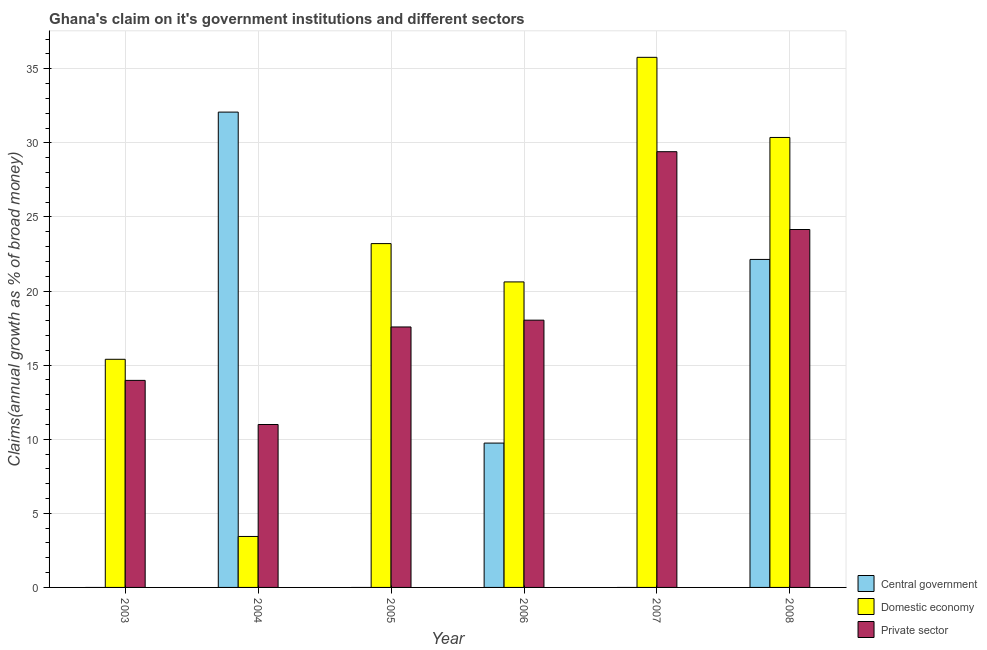How many different coloured bars are there?
Make the answer very short. 3. Are the number of bars per tick equal to the number of legend labels?
Provide a succinct answer. No. Are the number of bars on each tick of the X-axis equal?
Ensure brevity in your answer.  No. How many bars are there on the 6th tick from the left?
Offer a very short reply. 3. What is the percentage of claim on the private sector in 2004?
Offer a terse response. 10.99. Across all years, what is the maximum percentage of claim on the central government?
Provide a short and direct response. 32.08. Across all years, what is the minimum percentage of claim on the domestic economy?
Make the answer very short. 3.44. What is the total percentage of claim on the domestic economy in the graph?
Offer a very short reply. 128.79. What is the difference between the percentage of claim on the domestic economy in 2004 and that in 2008?
Offer a very short reply. -26.93. What is the difference between the percentage of claim on the private sector in 2007 and the percentage of claim on the central government in 2008?
Your response must be concise. 5.25. What is the average percentage of claim on the domestic economy per year?
Provide a succinct answer. 21.47. In the year 2003, what is the difference between the percentage of claim on the private sector and percentage of claim on the central government?
Your response must be concise. 0. What is the ratio of the percentage of claim on the private sector in 2004 to that in 2008?
Give a very brief answer. 0.46. Is the percentage of claim on the domestic economy in 2004 less than that in 2007?
Give a very brief answer. Yes. What is the difference between the highest and the second highest percentage of claim on the central government?
Your answer should be very brief. 9.94. What is the difference between the highest and the lowest percentage of claim on the central government?
Offer a very short reply. 32.08. Is the sum of the percentage of claim on the domestic economy in 2006 and 2008 greater than the maximum percentage of claim on the private sector across all years?
Make the answer very short. Yes. Is it the case that in every year, the sum of the percentage of claim on the central government and percentage of claim on the domestic economy is greater than the percentage of claim on the private sector?
Ensure brevity in your answer.  Yes. Are all the bars in the graph horizontal?
Your answer should be compact. No. Are the values on the major ticks of Y-axis written in scientific E-notation?
Keep it short and to the point. No. Does the graph contain any zero values?
Your response must be concise. Yes. Where does the legend appear in the graph?
Your response must be concise. Bottom right. How are the legend labels stacked?
Your answer should be very brief. Vertical. What is the title of the graph?
Provide a succinct answer. Ghana's claim on it's government institutions and different sectors. Does "Machinery" appear as one of the legend labels in the graph?
Provide a short and direct response. No. What is the label or title of the X-axis?
Ensure brevity in your answer.  Year. What is the label or title of the Y-axis?
Provide a short and direct response. Claims(annual growth as % of broad money). What is the Claims(annual growth as % of broad money) of Domestic economy in 2003?
Provide a succinct answer. 15.4. What is the Claims(annual growth as % of broad money) in Private sector in 2003?
Your answer should be compact. 13.97. What is the Claims(annual growth as % of broad money) of Central government in 2004?
Provide a short and direct response. 32.08. What is the Claims(annual growth as % of broad money) in Domestic economy in 2004?
Provide a short and direct response. 3.44. What is the Claims(annual growth as % of broad money) in Private sector in 2004?
Provide a short and direct response. 10.99. What is the Claims(annual growth as % of broad money) of Domestic economy in 2005?
Ensure brevity in your answer.  23.2. What is the Claims(annual growth as % of broad money) in Private sector in 2005?
Make the answer very short. 17.58. What is the Claims(annual growth as % of broad money) in Central government in 2006?
Keep it short and to the point. 9.74. What is the Claims(annual growth as % of broad money) in Domestic economy in 2006?
Provide a succinct answer. 20.62. What is the Claims(annual growth as % of broad money) in Private sector in 2006?
Give a very brief answer. 18.04. What is the Claims(annual growth as % of broad money) of Domestic economy in 2007?
Your response must be concise. 35.77. What is the Claims(annual growth as % of broad money) in Private sector in 2007?
Keep it short and to the point. 29.41. What is the Claims(annual growth as % of broad money) in Central government in 2008?
Your answer should be very brief. 22.13. What is the Claims(annual growth as % of broad money) of Domestic economy in 2008?
Your response must be concise. 30.37. What is the Claims(annual growth as % of broad money) of Private sector in 2008?
Your answer should be compact. 24.15. Across all years, what is the maximum Claims(annual growth as % of broad money) of Central government?
Keep it short and to the point. 32.08. Across all years, what is the maximum Claims(annual growth as % of broad money) in Domestic economy?
Your answer should be compact. 35.77. Across all years, what is the maximum Claims(annual growth as % of broad money) of Private sector?
Provide a short and direct response. 29.41. Across all years, what is the minimum Claims(annual growth as % of broad money) in Central government?
Ensure brevity in your answer.  0. Across all years, what is the minimum Claims(annual growth as % of broad money) in Domestic economy?
Your response must be concise. 3.44. Across all years, what is the minimum Claims(annual growth as % of broad money) in Private sector?
Give a very brief answer. 10.99. What is the total Claims(annual growth as % of broad money) of Central government in the graph?
Provide a short and direct response. 63.95. What is the total Claims(annual growth as % of broad money) of Domestic economy in the graph?
Offer a very short reply. 128.79. What is the total Claims(annual growth as % of broad money) of Private sector in the graph?
Your answer should be compact. 114.14. What is the difference between the Claims(annual growth as % of broad money) in Domestic economy in 2003 and that in 2004?
Offer a very short reply. 11.96. What is the difference between the Claims(annual growth as % of broad money) of Private sector in 2003 and that in 2004?
Make the answer very short. 2.98. What is the difference between the Claims(annual growth as % of broad money) of Domestic economy in 2003 and that in 2005?
Your response must be concise. -7.81. What is the difference between the Claims(annual growth as % of broad money) in Private sector in 2003 and that in 2005?
Your answer should be very brief. -3.61. What is the difference between the Claims(annual growth as % of broad money) of Domestic economy in 2003 and that in 2006?
Your answer should be very brief. -5.22. What is the difference between the Claims(annual growth as % of broad money) in Private sector in 2003 and that in 2006?
Keep it short and to the point. -4.06. What is the difference between the Claims(annual growth as % of broad money) of Domestic economy in 2003 and that in 2007?
Keep it short and to the point. -20.38. What is the difference between the Claims(annual growth as % of broad money) in Private sector in 2003 and that in 2007?
Make the answer very short. -15.43. What is the difference between the Claims(annual growth as % of broad money) of Domestic economy in 2003 and that in 2008?
Give a very brief answer. -14.97. What is the difference between the Claims(annual growth as % of broad money) of Private sector in 2003 and that in 2008?
Your answer should be very brief. -10.18. What is the difference between the Claims(annual growth as % of broad money) of Domestic economy in 2004 and that in 2005?
Provide a short and direct response. -19.76. What is the difference between the Claims(annual growth as % of broad money) in Private sector in 2004 and that in 2005?
Ensure brevity in your answer.  -6.58. What is the difference between the Claims(annual growth as % of broad money) in Central government in 2004 and that in 2006?
Offer a very short reply. 22.34. What is the difference between the Claims(annual growth as % of broad money) in Domestic economy in 2004 and that in 2006?
Keep it short and to the point. -17.18. What is the difference between the Claims(annual growth as % of broad money) in Private sector in 2004 and that in 2006?
Give a very brief answer. -7.04. What is the difference between the Claims(annual growth as % of broad money) in Domestic economy in 2004 and that in 2007?
Offer a terse response. -32.33. What is the difference between the Claims(annual growth as % of broad money) in Private sector in 2004 and that in 2007?
Provide a succinct answer. -18.41. What is the difference between the Claims(annual growth as % of broad money) in Central government in 2004 and that in 2008?
Provide a succinct answer. 9.94. What is the difference between the Claims(annual growth as % of broad money) in Domestic economy in 2004 and that in 2008?
Keep it short and to the point. -26.93. What is the difference between the Claims(annual growth as % of broad money) in Private sector in 2004 and that in 2008?
Your answer should be compact. -13.16. What is the difference between the Claims(annual growth as % of broad money) in Domestic economy in 2005 and that in 2006?
Give a very brief answer. 2.59. What is the difference between the Claims(annual growth as % of broad money) of Private sector in 2005 and that in 2006?
Your response must be concise. -0.46. What is the difference between the Claims(annual growth as % of broad money) of Domestic economy in 2005 and that in 2007?
Offer a terse response. -12.57. What is the difference between the Claims(annual growth as % of broad money) of Private sector in 2005 and that in 2007?
Provide a short and direct response. -11.83. What is the difference between the Claims(annual growth as % of broad money) of Domestic economy in 2005 and that in 2008?
Provide a succinct answer. -7.16. What is the difference between the Claims(annual growth as % of broad money) in Private sector in 2005 and that in 2008?
Your answer should be very brief. -6.58. What is the difference between the Claims(annual growth as % of broad money) of Domestic economy in 2006 and that in 2007?
Make the answer very short. -15.16. What is the difference between the Claims(annual growth as % of broad money) in Private sector in 2006 and that in 2007?
Offer a very short reply. -11.37. What is the difference between the Claims(annual growth as % of broad money) in Central government in 2006 and that in 2008?
Offer a very short reply. -12.39. What is the difference between the Claims(annual growth as % of broad money) in Domestic economy in 2006 and that in 2008?
Your answer should be very brief. -9.75. What is the difference between the Claims(annual growth as % of broad money) of Private sector in 2006 and that in 2008?
Make the answer very short. -6.12. What is the difference between the Claims(annual growth as % of broad money) in Domestic economy in 2007 and that in 2008?
Your answer should be very brief. 5.41. What is the difference between the Claims(annual growth as % of broad money) in Private sector in 2007 and that in 2008?
Your answer should be compact. 5.25. What is the difference between the Claims(annual growth as % of broad money) in Domestic economy in 2003 and the Claims(annual growth as % of broad money) in Private sector in 2004?
Your response must be concise. 4.4. What is the difference between the Claims(annual growth as % of broad money) in Domestic economy in 2003 and the Claims(annual growth as % of broad money) in Private sector in 2005?
Keep it short and to the point. -2.18. What is the difference between the Claims(annual growth as % of broad money) of Domestic economy in 2003 and the Claims(annual growth as % of broad money) of Private sector in 2006?
Keep it short and to the point. -2.64. What is the difference between the Claims(annual growth as % of broad money) of Domestic economy in 2003 and the Claims(annual growth as % of broad money) of Private sector in 2007?
Provide a succinct answer. -14.01. What is the difference between the Claims(annual growth as % of broad money) of Domestic economy in 2003 and the Claims(annual growth as % of broad money) of Private sector in 2008?
Offer a terse response. -8.76. What is the difference between the Claims(annual growth as % of broad money) of Central government in 2004 and the Claims(annual growth as % of broad money) of Domestic economy in 2005?
Provide a succinct answer. 8.87. What is the difference between the Claims(annual growth as % of broad money) in Central government in 2004 and the Claims(annual growth as % of broad money) in Private sector in 2005?
Make the answer very short. 14.5. What is the difference between the Claims(annual growth as % of broad money) of Domestic economy in 2004 and the Claims(annual growth as % of broad money) of Private sector in 2005?
Your response must be concise. -14.14. What is the difference between the Claims(annual growth as % of broad money) of Central government in 2004 and the Claims(annual growth as % of broad money) of Domestic economy in 2006?
Offer a very short reply. 11.46. What is the difference between the Claims(annual growth as % of broad money) of Central government in 2004 and the Claims(annual growth as % of broad money) of Private sector in 2006?
Give a very brief answer. 14.04. What is the difference between the Claims(annual growth as % of broad money) in Domestic economy in 2004 and the Claims(annual growth as % of broad money) in Private sector in 2006?
Give a very brief answer. -14.6. What is the difference between the Claims(annual growth as % of broad money) in Central government in 2004 and the Claims(annual growth as % of broad money) in Domestic economy in 2007?
Offer a terse response. -3.7. What is the difference between the Claims(annual growth as % of broad money) of Central government in 2004 and the Claims(annual growth as % of broad money) of Private sector in 2007?
Your response must be concise. 2.67. What is the difference between the Claims(annual growth as % of broad money) of Domestic economy in 2004 and the Claims(annual growth as % of broad money) of Private sector in 2007?
Your response must be concise. -25.97. What is the difference between the Claims(annual growth as % of broad money) of Central government in 2004 and the Claims(annual growth as % of broad money) of Domestic economy in 2008?
Your answer should be very brief. 1.71. What is the difference between the Claims(annual growth as % of broad money) in Central government in 2004 and the Claims(annual growth as % of broad money) in Private sector in 2008?
Give a very brief answer. 7.92. What is the difference between the Claims(annual growth as % of broad money) in Domestic economy in 2004 and the Claims(annual growth as % of broad money) in Private sector in 2008?
Your answer should be compact. -20.71. What is the difference between the Claims(annual growth as % of broad money) in Domestic economy in 2005 and the Claims(annual growth as % of broad money) in Private sector in 2006?
Offer a terse response. 5.17. What is the difference between the Claims(annual growth as % of broad money) of Domestic economy in 2005 and the Claims(annual growth as % of broad money) of Private sector in 2007?
Offer a terse response. -6.2. What is the difference between the Claims(annual growth as % of broad money) in Domestic economy in 2005 and the Claims(annual growth as % of broad money) in Private sector in 2008?
Provide a short and direct response. -0.95. What is the difference between the Claims(annual growth as % of broad money) of Central government in 2006 and the Claims(annual growth as % of broad money) of Domestic economy in 2007?
Your answer should be compact. -26.03. What is the difference between the Claims(annual growth as % of broad money) of Central government in 2006 and the Claims(annual growth as % of broad money) of Private sector in 2007?
Ensure brevity in your answer.  -19.66. What is the difference between the Claims(annual growth as % of broad money) of Domestic economy in 2006 and the Claims(annual growth as % of broad money) of Private sector in 2007?
Offer a very short reply. -8.79. What is the difference between the Claims(annual growth as % of broad money) in Central government in 2006 and the Claims(annual growth as % of broad money) in Domestic economy in 2008?
Provide a succinct answer. -20.63. What is the difference between the Claims(annual growth as % of broad money) in Central government in 2006 and the Claims(annual growth as % of broad money) in Private sector in 2008?
Give a very brief answer. -14.41. What is the difference between the Claims(annual growth as % of broad money) of Domestic economy in 2006 and the Claims(annual growth as % of broad money) of Private sector in 2008?
Offer a very short reply. -3.54. What is the difference between the Claims(annual growth as % of broad money) of Domestic economy in 2007 and the Claims(annual growth as % of broad money) of Private sector in 2008?
Provide a short and direct response. 11.62. What is the average Claims(annual growth as % of broad money) of Central government per year?
Offer a very short reply. 10.66. What is the average Claims(annual growth as % of broad money) of Domestic economy per year?
Your response must be concise. 21.47. What is the average Claims(annual growth as % of broad money) of Private sector per year?
Your answer should be compact. 19.02. In the year 2003, what is the difference between the Claims(annual growth as % of broad money) of Domestic economy and Claims(annual growth as % of broad money) of Private sector?
Ensure brevity in your answer.  1.42. In the year 2004, what is the difference between the Claims(annual growth as % of broad money) in Central government and Claims(annual growth as % of broad money) in Domestic economy?
Your answer should be very brief. 28.64. In the year 2004, what is the difference between the Claims(annual growth as % of broad money) in Central government and Claims(annual growth as % of broad money) in Private sector?
Give a very brief answer. 21.08. In the year 2004, what is the difference between the Claims(annual growth as % of broad money) in Domestic economy and Claims(annual growth as % of broad money) in Private sector?
Your response must be concise. -7.55. In the year 2005, what is the difference between the Claims(annual growth as % of broad money) in Domestic economy and Claims(annual growth as % of broad money) in Private sector?
Ensure brevity in your answer.  5.63. In the year 2006, what is the difference between the Claims(annual growth as % of broad money) in Central government and Claims(annual growth as % of broad money) in Domestic economy?
Provide a short and direct response. -10.88. In the year 2006, what is the difference between the Claims(annual growth as % of broad money) of Central government and Claims(annual growth as % of broad money) of Private sector?
Provide a succinct answer. -8.3. In the year 2006, what is the difference between the Claims(annual growth as % of broad money) in Domestic economy and Claims(annual growth as % of broad money) in Private sector?
Provide a succinct answer. 2.58. In the year 2007, what is the difference between the Claims(annual growth as % of broad money) in Domestic economy and Claims(annual growth as % of broad money) in Private sector?
Your response must be concise. 6.37. In the year 2008, what is the difference between the Claims(annual growth as % of broad money) of Central government and Claims(annual growth as % of broad money) of Domestic economy?
Provide a succinct answer. -8.23. In the year 2008, what is the difference between the Claims(annual growth as % of broad money) in Central government and Claims(annual growth as % of broad money) in Private sector?
Make the answer very short. -2.02. In the year 2008, what is the difference between the Claims(annual growth as % of broad money) of Domestic economy and Claims(annual growth as % of broad money) of Private sector?
Provide a short and direct response. 6.21. What is the ratio of the Claims(annual growth as % of broad money) of Domestic economy in 2003 to that in 2004?
Provide a succinct answer. 4.48. What is the ratio of the Claims(annual growth as % of broad money) of Private sector in 2003 to that in 2004?
Provide a short and direct response. 1.27. What is the ratio of the Claims(annual growth as % of broad money) in Domestic economy in 2003 to that in 2005?
Ensure brevity in your answer.  0.66. What is the ratio of the Claims(annual growth as % of broad money) of Private sector in 2003 to that in 2005?
Give a very brief answer. 0.79. What is the ratio of the Claims(annual growth as % of broad money) of Domestic economy in 2003 to that in 2006?
Offer a terse response. 0.75. What is the ratio of the Claims(annual growth as % of broad money) in Private sector in 2003 to that in 2006?
Offer a terse response. 0.77. What is the ratio of the Claims(annual growth as % of broad money) in Domestic economy in 2003 to that in 2007?
Provide a succinct answer. 0.43. What is the ratio of the Claims(annual growth as % of broad money) of Private sector in 2003 to that in 2007?
Offer a very short reply. 0.48. What is the ratio of the Claims(annual growth as % of broad money) in Domestic economy in 2003 to that in 2008?
Make the answer very short. 0.51. What is the ratio of the Claims(annual growth as % of broad money) in Private sector in 2003 to that in 2008?
Give a very brief answer. 0.58. What is the ratio of the Claims(annual growth as % of broad money) in Domestic economy in 2004 to that in 2005?
Your answer should be compact. 0.15. What is the ratio of the Claims(annual growth as % of broad money) in Private sector in 2004 to that in 2005?
Provide a succinct answer. 0.63. What is the ratio of the Claims(annual growth as % of broad money) of Central government in 2004 to that in 2006?
Give a very brief answer. 3.29. What is the ratio of the Claims(annual growth as % of broad money) of Domestic economy in 2004 to that in 2006?
Offer a terse response. 0.17. What is the ratio of the Claims(annual growth as % of broad money) of Private sector in 2004 to that in 2006?
Keep it short and to the point. 0.61. What is the ratio of the Claims(annual growth as % of broad money) in Domestic economy in 2004 to that in 2007?
Offer a very short reply. 0.1. What is the ratio of the Claims(annual growth as % of broad money) in Private sector in 2004 to that in 2007?
Your response must be concise. 0.37. What is the ratio of the Claims(annual growth as % of broad money) of Central government in 2004 to that in 2008?
Provide a short and direct response. 1.45. What is the ratio of the Claims(annual growth as % of broad money) in Domestic economy in 2004 to that in 2008?
Your answer should be very brief. 0.11. What is the ratio of the Claims(annual growth as % of broad money) in Private sector in 2004 to that in 2008?
Ensure brevity in your answer.  0.46. What is the ratio of the Claims(annual growth as % of broad money) of Domestic economy in 2005 to that in 2006?
Provide a succinct answer. 1.13. What is the ratio of the Claims(annual growth as % of broad money) of Private sector in 2005 to that in 2006?
Provide a short and direct response. 0.97. What is the ratio of the Claims(annual growth as % of broad money) in Domestic economy in 2005 to that in 2007?
Your response must be concise. 0.65. What is the ratio of the Claims(annual growth as % of broad money) in Private sector in 2005 to that in 2007?
Give a very brief answer. 0.6. What is the ratio of the Claims(annual growth as % of broad money) in Domestic economy in 2005 to that in 2008?
Make the answer very short. 0.76. What is the ratio of the Claims(annual growth as % of broad money) of Private sector in 2005 to that in 2008?
Offer a terse response. 0.73. What is the ratio of the Claims(annual growth as % of broad money) of Domestic economy in 2006 to that in 2007?
Ensure brevity in your answer.  0.58. What is the ratio of the Claims(annual growth as % of broad money) of Private sector in 2006 to that in 2007?
Your answer should be compact. 0.61. What is the ratio of the Claims(annual growth as % of broad money) of Central government in 2006 to that in 2008?
Ensure brevity in your answer.  0.44. What is the ratio of the Claims(annual growth as % of broad money) in Domestic economy in 2006 to that in 2008?
Ensure brevity in your answer.  0.68. What is the ratio of the Claims(annual growth as % of broad money) of Private sector in 2006 to that in 2008?
Provide a succinct answer. 0.75. What is the ratio of the Claims(annual growth as % of broad money) in Domestic economy in 2007 to that in 2008?
Provide a short and direct response. 1.18. What is the ratio of the Claims(annual growth as % of broad money) of Private sector in 2007 to that in 2008?
Your response must be concise. 1.22. What is the difference between the highest and the second highest Claims(annual growth as % of broad money) of Central government?
Your answer should be very brief. 9.94. What is the difference between the highest and the second highest Claims(annual growth as % of broad money) in Domestic economy?
Make the answer very short. 5.41. What is the difference between the highest and the second highest Claims(annual growth as % of broad money) of Private sector?
Give a very brief answer. 5.25. What is the difference between the highest and the lowest Claims(annual growth as % of broad money) of Central government?
Give a very brief answer. 32.08. What is the difference between the highest and the lowest Claims(annual growth as % of broad money) in Domestic economy?
Give a very brief answer. 32.33. What is the difference between the highest and the lowest Claims(annual growth as % of broad money) of Private sector?
Provide a succinct answer. 18.41. 